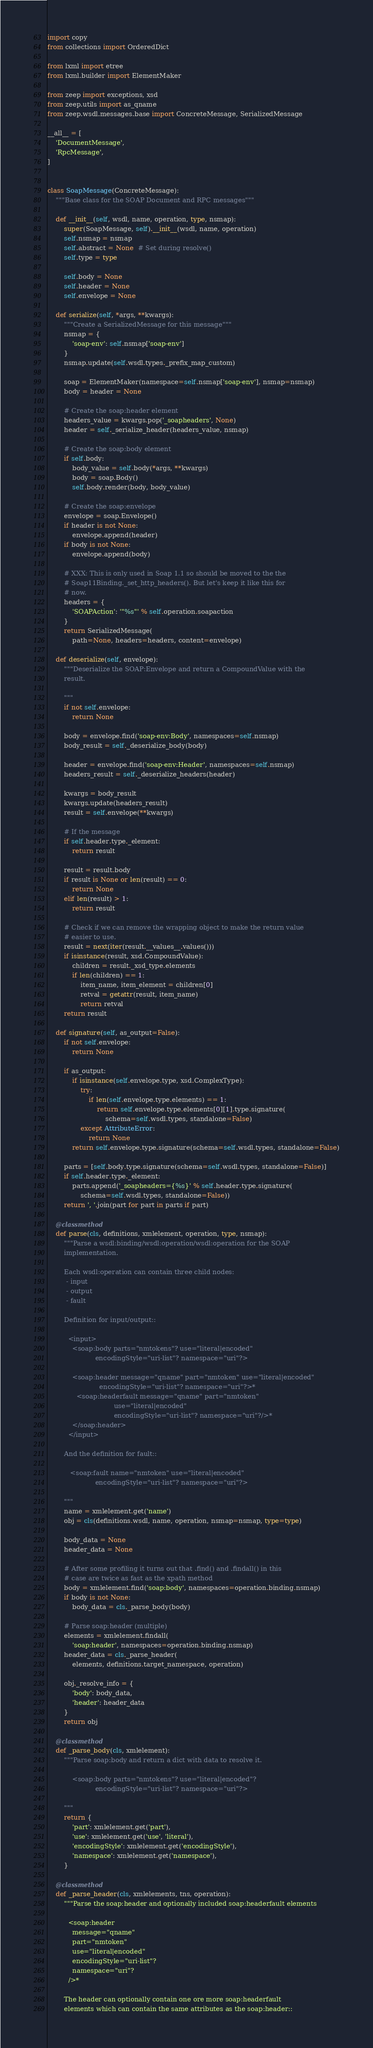Convert code to text. <code><loc_0><loc_0><loc_500><loc_500><_Python_>import copy
from collections import OrderedDict

from lxml import etree
from lxml.builder import ElementMaker

from zeep import exceptions, xsd
from zeep.utils import as_qname
from zeep.wsdl.messages.base import ConcreteMessage, SerializedMessage

__all__ = [
    'DocumentMessage',
    'RpcMessage',
]


class SoapMessage(ConcreteMessage):
    """Base class for the SOAP Document and RPC messages"""

    def __init__(self, wsdl, name, operation, type, nsmap):
        super(SoapMessage, self).__init__(wsdl, name, operation)
        self.nsmap = nsmap
        self.abstract = None  # Set during resolve()
        self.type = type

        self.body = None
        self.header = None
        self.envelope = None

    def serialize(self, *args, **kwargs):
        """Create a SerializedMessage for this message"""
        nsmap = {
            'soap-env': self.nsmap['soap-env']
        }
        nsmap.update(self.wsdl.types._prefix_map_custom)

        soap = ElementMaker(namespace=self.nsmap['soap-env'], nsmap=nsmap)
        body = header = None

        # Create the soap:header element
        headers_value = kwargs.pop('_soapheaders', None)
        header = self._serialize_header(headers_value, nsmap)

        # Create the soap:body element
        if self.body:
            body_value = self.body(*args, **kwargs)
            body = soap.Body()
            self.body.render(body, body_value)

        # Create the soap:envelope
        envelope = soap.Envelope()
        if header is not None:
            envelope.append(header)
        if body is not None:
            envelope.append(body)

        # XXX: This is only used in Soap 1.1 so should be moved to the the
        # Soap11Binding._set_http_headers(). But let's keep it like this for
        # now.
        headers = {
            'SOAPAction': '"%s"' % self.operation.soapaction
        }
        return SerializedMessage(
            path=None, headers=headers, content=envelope)

    def deserialize(self, envelope):
        """Deserialize the SOAP:Envelope and return a CompoundValue with the
        result.

        """
        if not self.envelope:
            return None

        body = envelope.find('soap-env:Body', namespaces=self.nsmap)
        body_result = self._deserialize_body(body)

        header = envelope.find('soap-env:Header', namespaces=self.nsmap)
        headers_result = self._deserialize_headers(header)

        kwargs = body_result
        kwargs.update(headers_result)
        result = self.envelope(**kwargs)

        # If the message
        if self.header.type._element:
            return result

        result = result.body
        if result is None or len(result) == 0:
            return None
        elif len(result) > 1:
            return result

        # Check if we can remove the wrapping object to make the return value
        # easier to use.
        result = next(iter(result.__values__.values()))
        if isinstance(result, xsd.CompoundValue):
            children = result._xsd_type.elements
            if len(children) == 1:
                item_name, item_element = children[0]
                retval = getattr(result, item_name)
                return retval
        return result

    def signature(self, as_output=False):
        if not self.envelope:
            return None

        if as_output:
            if isinstance(self.envelope.type, xsd.ComplexType):
                try:
                    if len(self.envelope.type.elements) == 1:
                        return self.envelope.type.elements[0][1].type.signature(
                            schema=self.wsdl.types, standalone=False)
                except AttributeError:
                    return None
            return self.envelope.type.signature(schema=self.wsdl.types, standalone=False)

        parts = [self.body.type.signature(schema=self.wsdl.types, standalone=False)]
        if self.header.type._element:
            parts.append('_soapheaders={%s}' % self.header.type.signature(
                schema=self.wsdl.types, standalone=False))
        return ', '.join(part for part in parts if part)

    @classmethod
    def parse(cls, definitions, xmlelement, operation, type, nsmap):
        """Parse a wsdl:binding/wsdl:operation/wsdl:operation for the SOAP
        implementation.

        Each wsdl:operation can contain three child nodes:
         - input
         - output
         - fault

        Definition for input/output::

          <input>
            <soap:body parts="nmtokens"? use="literal|encoded"
                       encodingStyle="uri-list"? namespace="uri"?>

            <soap:header message="qname" part="nmtoken" use="literal|encoded"
                         encodingStyle="uri-list"? namespace="uri"?>*
              <soap:headerfault message="qname" part="nmtoken"
                                use="literal|encoded"
                                encodingStyle="uri-list"? namespace="uri"?/>*
            </soap:header>
          </input>

        And the definition for fault::

           <soap:fault name="nmtoken" use="literal|encoded"
                       encodingStyle="uri-list"? namespace="uri"?>

        """
        name = xmlelement.get('name')
        obj = cls(definitions.wsdl, name, operation, nsmap=nsmap, type=type)

        body_data = None
        header_data = None

        # After some profiling it turns out that .find() and .findall() in this
        # case are twice as fast as the xpath method
        body = xmlelement.find('soap:body', namespaces=operation.binding.nsmap)
        if body is not None:
            body_data = cls._parse_body(body)

        # Parse soap:header (multiple)
        elements = xmlelement.findall(
            'soap:header', namespaces=operation.binding.nsmap)
        header_data = cls._parse_header(
            elements, definitions.target_namespace, operation)

        obj._resolve_info = {
            'body': body_data,
            'header': header_data
        }
        return obj

    @classmethod
    def _parse_body(cls, xmlelement):
        """Parse soap:body and return a dict with data to resolve it.

            <soap:body parts="nmtokens"? use="literal|encoded"?
                       encodingStyle="uri-list"? namespace="uri"?>

        """
        return {
            'part': xmlelement.get('part'),
            'use': xmlelement.get('use', 'literal'),
            'encodingStyle': xmlelement.get('encodingStyle'),
            'namespace': xmlelement.get('namespace'),
        }

    @classmethod
    def _parse_header(cls, xmlelements, tns, operation):
        """Parse the soap:header and optionally included soap:headerfault elements

          <soap:header
            message="qname"
            part="nmtoken"
            use="literal|encoded"
            encodingStyle="uri-list"?
            namespace="uri"?
          />*

        The header can optionally contain one ore more soap:headerfault
        elements which can contain the same attributes as the soap:header::
</code> 